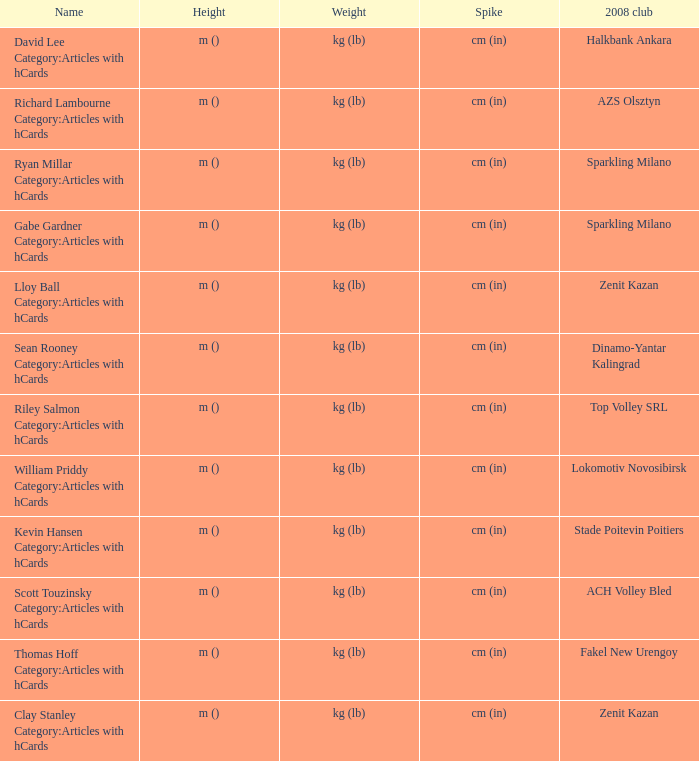What name has Fakel New Urengoy as the 2008 club? Thomas Hoff Category:Articles with hCards. 